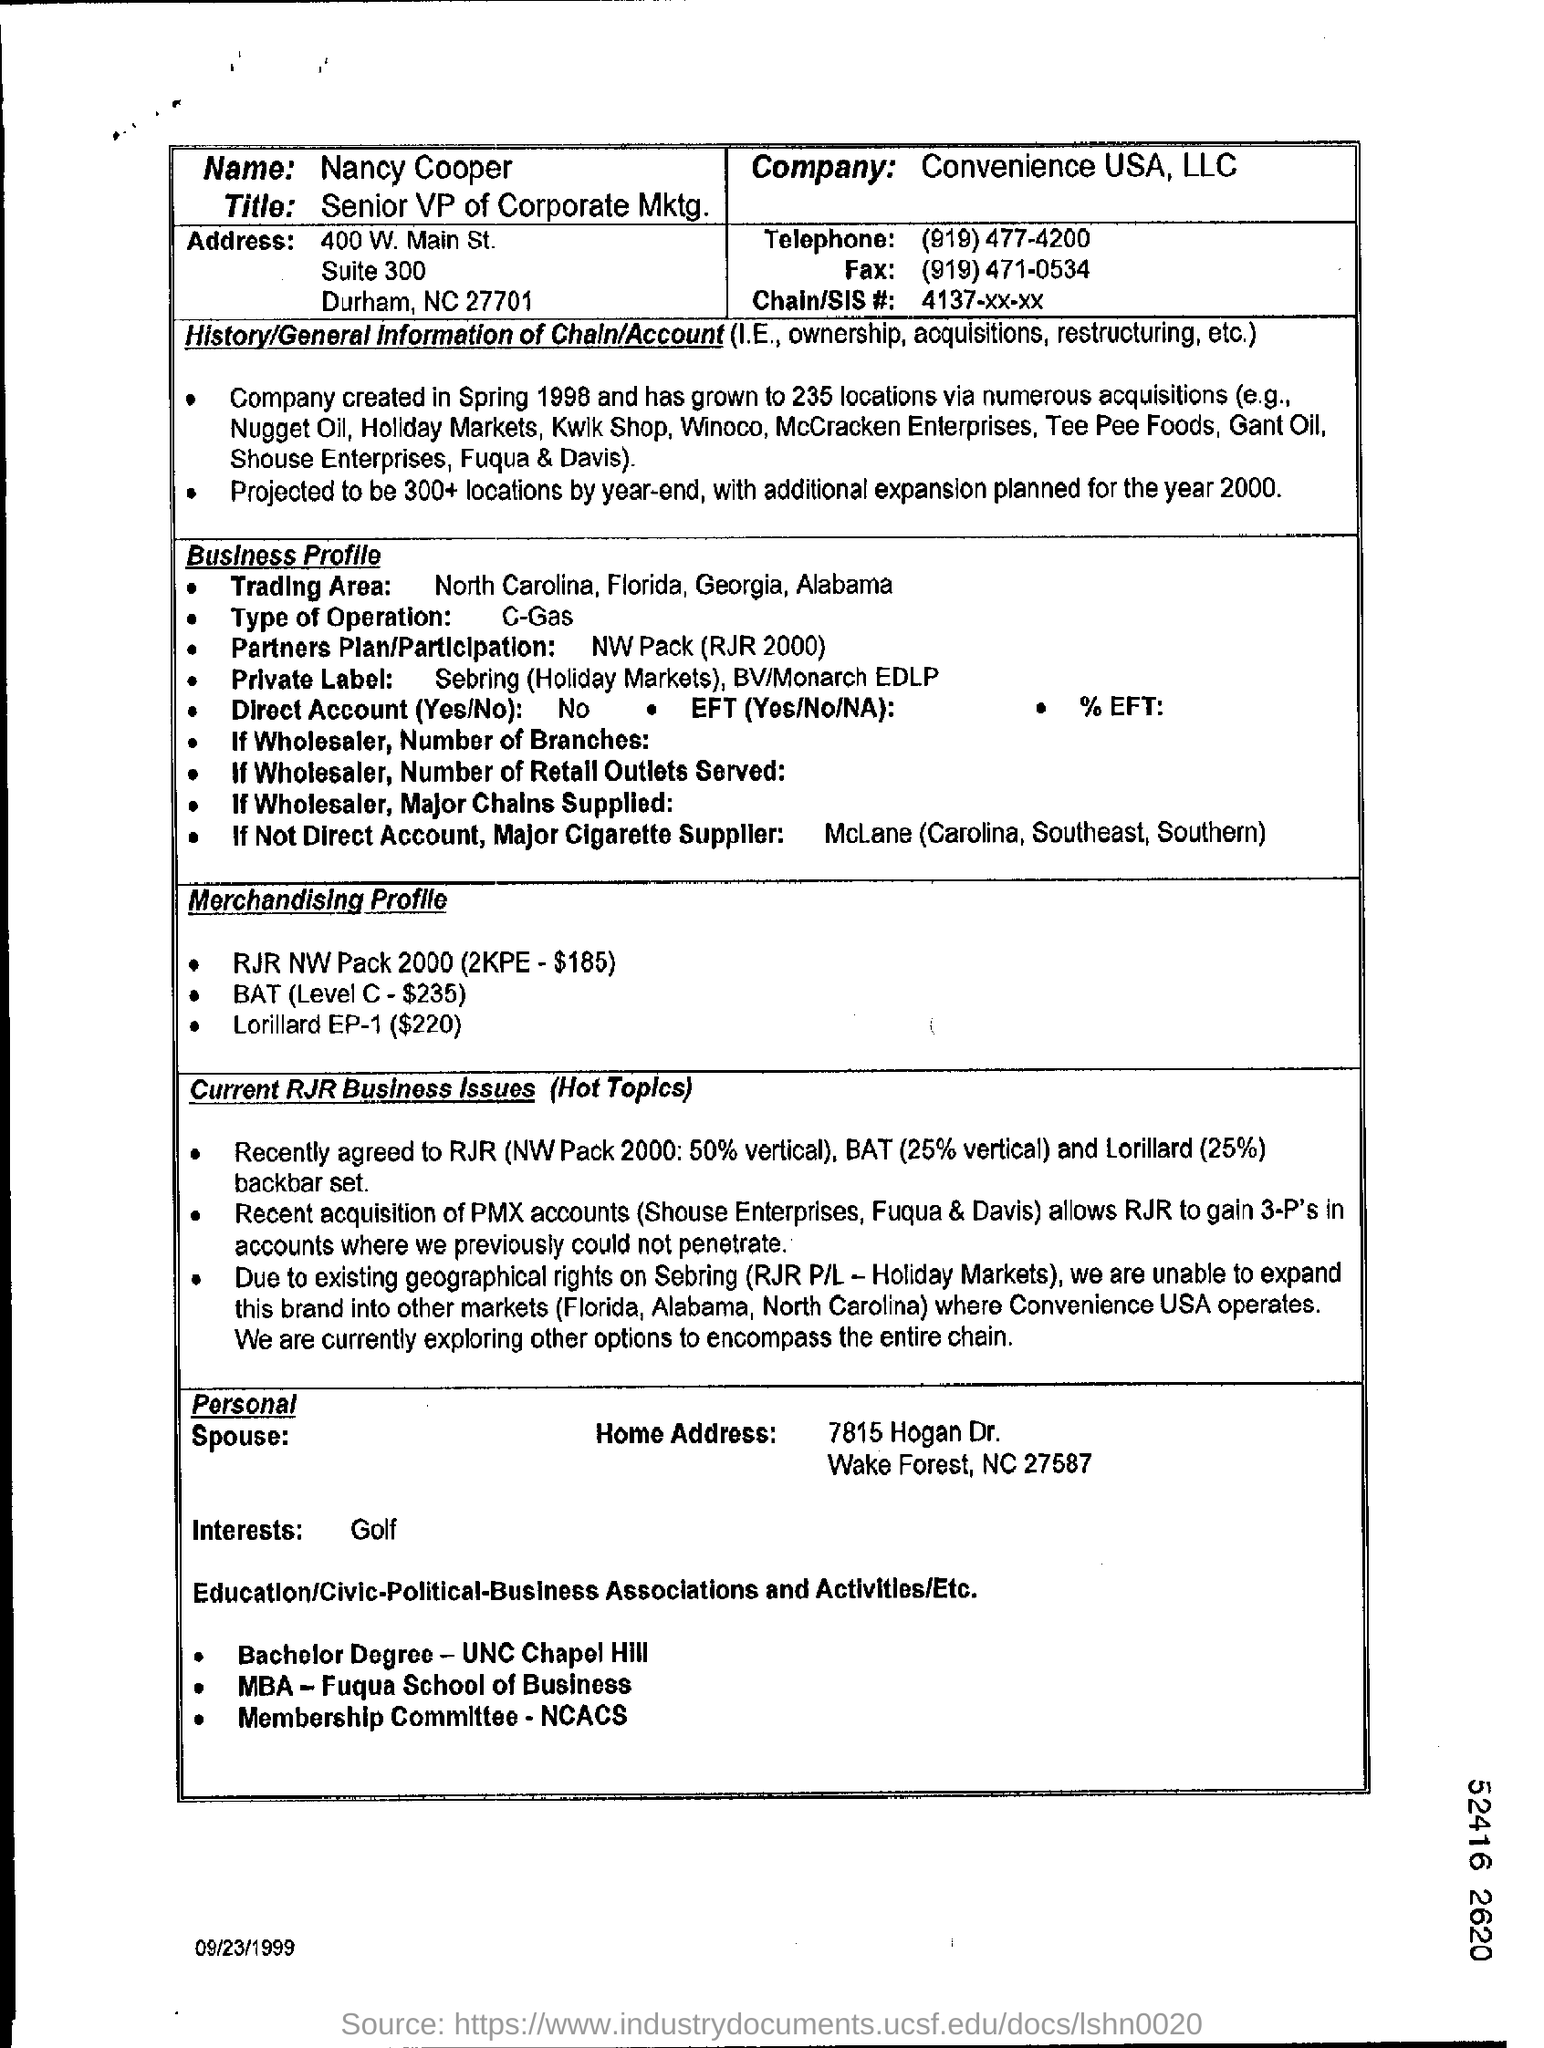What is the name of company?
Provide a short and direct response. Convenience USA, LLC. What is the telephone number?
Offer a very short reply. (919) 477-4200. 